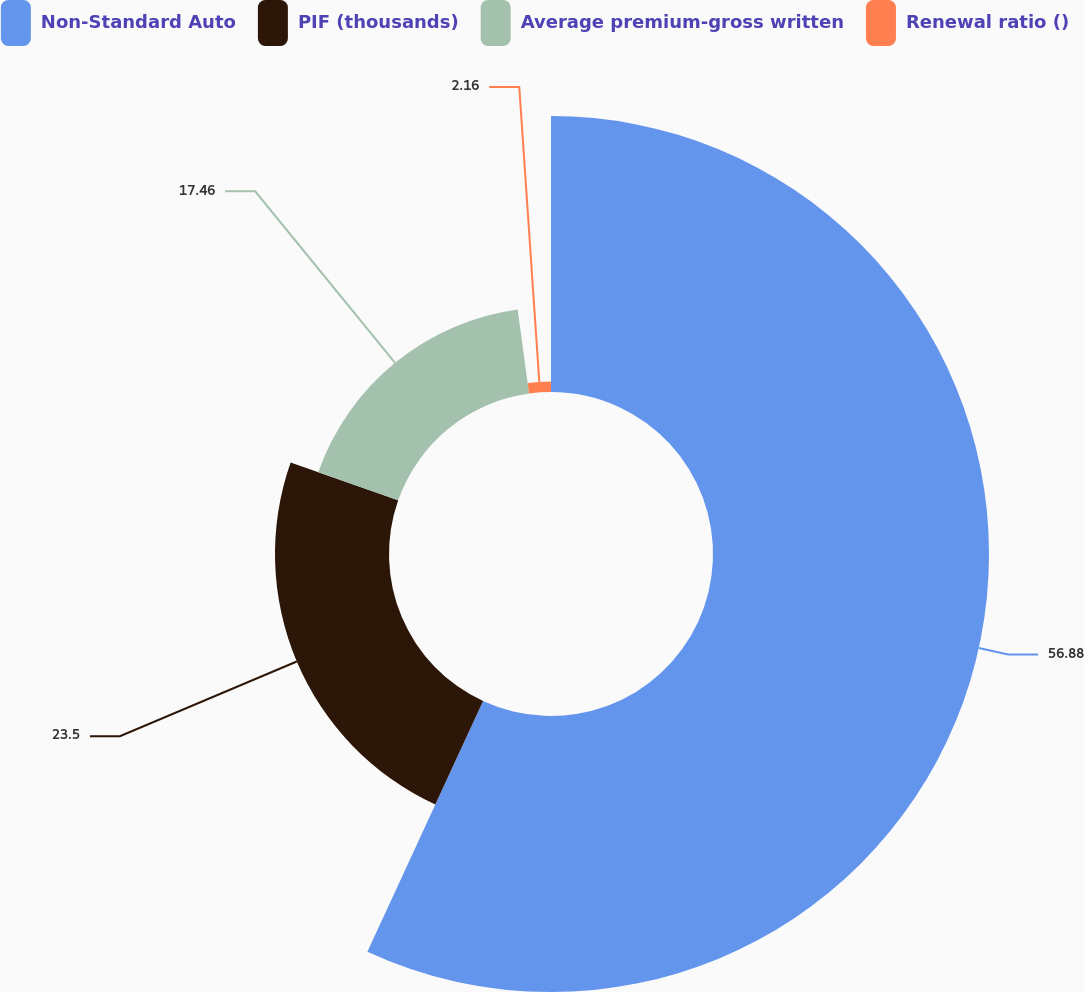<chart> <loc_0><loc_0><loc_500><loc_500><pie_chart><fcel>Non-Standard Auto<fcel>PIF (thousands)<fcel>Average premium-gross written<fcel>Renewal ratio ()<nl><fcel>56.89%<fcel>23.5%<fcel>17.46%<fcel>2.16%<nl></chart> 